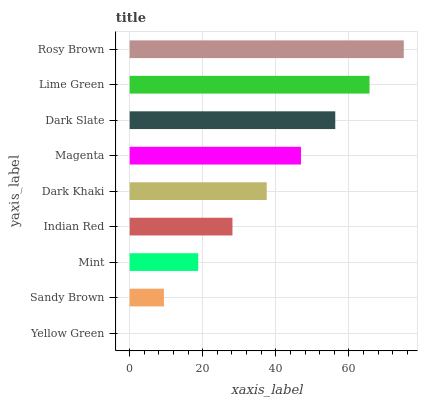Is Yellow Green the minimum?
Answer yes or no. Yes. Is Rosy Brown the maximum?
Answer yes or no. Yes. Is Sandy Brown the minimum?
Answer yes or no. No. Is Sandy Brown the maximum?
Answer yes or no. No. Is Sandy Brown greater than Yellow Green?
Answer yes or no. Yes. Is Yellow Green less than Sandy Brown?
Answer yes or no. Yes. Is Yellow Green greater than Sandy Brown?
Answer yes or no. No. Is Sandy Brown less than Yellow Green?
Answer yes or no. No. Is Dark Khaki the high median?
Answer yes or no. Yes. Is Dark Khaki the low median?
Answer yes or no. Yes. Is Lime Green the high median?
Answer yes or no. No. Is Lime Green the low median?
Answer yes or no. No. 